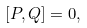<formula> <loc_0><loc_0><loc_500><loc_500>[ P , Q ] = 0 ,</formula> 